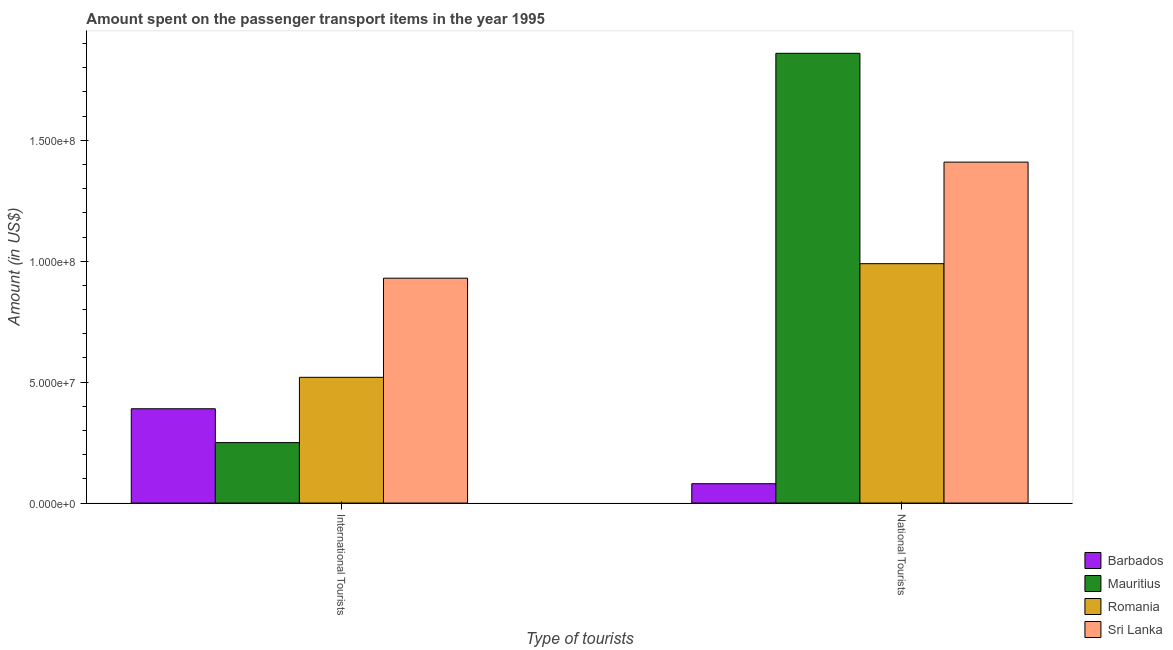How many different coloured bars are there?
Provide a short and direct response. 4. How many groups of bars are there?
Keep it short and to the point. 2. Are the number of bars per tick equal to the number of legend labels?
Ensure brevity in your answer.  Yes. How many bars are there on the 2nd tick from the left?
Give a very brief answer. 4. How many bars are there on the 1st tick from the right?
Provide a short and direct response. 4. What is the label of the 1st group of bars from the left?
Provide a succinct answer. International Tourists. What is the amount spent on transport items of national tourists in Mauritius?
Your answer should be compact. 1.86e+08. Across all countries, what is the maximum amount spent on transport items of national tourists?
Your answer should be very brief. 1.86e+08. Across all countries, what is the minimum amount spent on transport items of international tourists?
Provide a short and direct response. 2.50e+07. In which country was the amount spent on transport items of national tourists maximum?
Keep it short and to the point. Mauritius. In which country was the amount spent on transport items of national tourists minimum?
Offer a terse response. Barbados. What is the total amount spent on transport items of international tourists in the graph?
Give a very brief answer. 2.09e+08. What is the difference between the amount spent on transport items of national tourists in Romania and that in Barbados?
Make the answer very short. 9.10e+07. What is the difference between the amount spent on transport items of international tourists in Barbados and the amount spent on transport items of national tourists in Mauritius?
Ensure brevity in your answer.  -1.47e+08. What is the average amount spent on transport items of national tourists per country?
Offer a very short reply. 1.08e+08. What is the difference between the amount spent on transport items of national tourists and amount spent on transport items of international tourists in Romania?
Offer a very short reply. 4.70e+07. What is the ratio of the amount spent on transport items of international tourists in Barbados to that in Mauritius?
Your answer should be very brief. 1.56. Is the amount spent on transport items of international tourists in Barbados less than that in Sri Lanka?
Your answer should be compact. Yes. In how many countries, is the amount spent on transport items of national tourists greater than the average amount spent on transport items of national tourists taken over all countries?
Your answer should be very brief. 2. What does the 3rd bar from the left in International Tourists represents?
Ensure brevity in your answer.  Romania. What does the 2nd bar from the right in National Tourists represents?
Ensure brevity in your answer.  Romania. How many bars are there?
Keep it short and to the point. 8. How many countries are there in the graph?
Provide a succinct answer. 4. Are the values on the major ticks of Y-axis written in scientific E-notation?
Your response must be concise. Yes. Does the graph contain grids?
Your response must be concise. No. Where does the legend appear in the graph?
Provide a short and direct response. Bottom right. How many legend labels are there?
Your answer should be compact. 4. What is the title of the graph?
Make the answer very short. Amount spent on the passenger transport items in the year 1995. What is the label or title of the X-axis?
Your answer should be compact. Type of tourists. What is the label or title of the Y-axis?
Keep it short and to the point. Amount (in US$). What is the Amount (in US$) in Barbados in International Tourists?
Provide a succinct answer. 3.90e+07. What is the Amount (in US$) in Mauritius in International Tourists?
Your response must be concise. 2.50e+07. What is the Amount (in US$) in Romania in International Tourists?
Offer a very short reply. 5.20e+07. What is the Amount (in US$) of Sri Lanka in International Tourists?
Give a very brief answer. 9.30e+07. What is the Amount (in US$) in Mauritius in National Tourists?
Offer a terse response. 1.86e+08. What is the Amount (in US$) of Romania in National Tourists?
Keep it short and to the point. 9.90e+07. What is the Amount (in US$) in Sri Lanka in National Tourists?
Make the answer very short. 1.41e+08. Across all Type of tourists, what is the maximum Amount (in US$) in Barbados?
Ensure brevity in your answer.  3.90e+07. Across all Type of tourists, what is the maximum Amount (in US$) of Mauritius?
Your answer should be very brief. 1.86e+08. Across all Type of tourists, what is the maximum Amount (in US$) in Romania?
Your answer should be compact. 9.90e+07. Across all Type of tourists, what is the maximum Amount (in US$) of Sri Lanka?
Give a very brief answer. 1.41e+08. Across all Type of tourists, what is the minimum Amount (in US$) of Mauritius?
Provide a short and direct response. 2.50e+07. Across all Type of tourists, what is the minimum Amount (in US$) in Romania?
Provide a succinct answer. 5.20e+07. Across all Type of tourists, what is the minimum Amount (in US$) in Sri Lanka?
Give a very brief answer. 9.30e+07. What is the total Amount (in US$) in Barbados in the graph?
Keep it short and to the point. 4.70e+07. What is the total Amount (in US$) of Mauritius in the graph?
Your response must be concise. 2.11e+08. What is the total Amount (in US$) of Romania in the graph?
Your answer should be compact. 1.51e+08. What is the total Amount (in US$) in Sri Lanka in the graph?
Provide a succinct answer. 2.34e+08. What is the difference between the Amount (in US$) of Barbados in International Tourists and that in National Tourists?
Ensure brevity in your answer.  3.10e+07. What is the difference between the Amount (in US$) in Mauritius in International Tourists and that in National Tourists?
Provide a succinct answer. -1.61e+08. What is the difference between the Amount (in US$) in Romania in International Tourists and that in National Tourists?
Keep it short and to the point. -4.70e+07. What is the difference between the Amount (in US$) of Sri Lanka in International Tourists and that in National Tourists?
Give a very brief answer. -4.80e+07. What is the difference between the Amount (in US$) in Barbados in International Tourists and the Amount (in US$) in Mauritius in National Tourists?
Your answer should be compact. -1.47e+08. What is the difference between the Amount (in US$) in Barbados in International Tourists and the Amount (in US$) in Romania in National Tourists?
Offer a terse response. -6.00e+07. What is the difference between the Amount (in US$) of Barbados in International Tourists and the Amount (in US$) of Sri Lanka in National Tourists?
Keep it short and to the point. -1.02e+08. What is the difference between the Amount (in US$) of Mauritius in International Tourists and the Amount (in US$) of Romania in National Tourists?
Give a very brief answer. -7.40e+07. What is the difference between the Amount (in US$) in Mauritius in International Tourists and the Amount (in US$) in Sri Lanka in National Tourists?
Ensure brevity in your answer.  -1.16e+08. What is the difference between the Amount (in US$) in Romania in International Tourists and the Amount (in US$) in Sri Lanka in National Tourists?
Make the answer very short. -8.90e+07. What is the average Amount (in US$) in Barbados per Type of tourists?
Provide a short and direct response. 2.35e+07. What is the average Amount (in US$) of Mauritius per Type of tourists?
Keep it short and to the point. 1.06e+08. What is the average Amount (in US$) of Romania per Type of tourists?
Provide a succinct answer. 7.55e+07. What is the average Amount (in US$) in Sri Lanka per Type of tourists?
Ensure brevity in your answer.  1.17e+08. What is the difference between the Amount (in US$) of Barbados and Amount (in US$) of Mauritius in International Tourists?
Offer a terse response. 1.40e+07. What is the difference between the Amount (in US$) in Barbados and Amount (in US$) in Romania in International Tourists?
Offer a very short reply. -1.30e+07. What is the difference between the Amount (in US$) in Barbados and Amount (in US$) in Sri Lanka in International Tourists?
Give a very brief answer. -5.40e+07. What is the difference between the Amount (in US$) in Mauritius and Amount (in US$) in Romania in International Tourists?
Ensure brevity in your answer.  -2.70e+07. What is the difference between the Amount (in US$) in Mauritius and Amount (in US$) in Sri Lanka in International Tourists?
Make the answer very short. -6.80e+07. What is the difference between the Amount (in US$) of Romania and Amount (in US$) of Sri Lanka in International Tourists?
Your answer should be compact. -4.10e+07. What is the difference between the Amount (in US$) of Barbados and Amount (in US$) of Mauritius in National Tourists?
Your answer should be very brief. -1.78e+08. What is the difference between the Amount (in US$) of Barbados and Amount (in US$) of Romania in National Tourists?
Your answer should be compact. -9.10e+07. What is the difference between the Amount (in US$) in Barbados and Amount (in US$) in Sri Lanka in National Tourists?
Provide a succinct answer. -1.33e+08. What is the difference between the Amount (in US$) of Mauritius and Amount (in US$) of Romania in National Tourists?
Give a very brief answer. 8.70e+07. What is the difference between the Amount (in US$) in Mauritius and Amount (in US$) in Sri Lanka in National Tourists?
Your answer should be very brief. 4.50e+07. What is the difference between the Amount (in US$) of Romania and Amount (in US$) of Sri Lanka in National Tourists?
Your answer should be very brief. -4.20e+07. What is the ratio of the Amount (in US$) in Barbados in International Tourists to that in National Tourists?
Provide a short and direct response. 4.88. What is the ratio of the Amount (in US$) of Mauritius in International Tourists to that in National Tourists?
Keep it short and to the point. 0.13. What is the ratio of the Amount (in US$) in Romania in International Tourists to that in National Tourists?
Your response must be concise. 0.53. What is the ratio of the Amount (in US$) in Sri Lanka in International Tourists to that in National Tourists?
Offer a terse response. 0.66. What is the difference between the highest and the second highest Amount (in US$) of Barbados?
Provide a short and direct response. 3.10e+07. What is the difference between the highest and the second highest Amount (in US$) in Mauritius?
Offer a terse response. 1.61e+08. What is the difference between the highest and the second highest Amount (in US$) in Romania?
Make the answer very short. 4.70e+07. What is the difference between the highest and the second highest Amount (in US$) of Sri Lanka?
Make the answer very short. 4.80e+07. What is the difference between the highest and the lowest Amount (in US$) of Barbados?
Make the answer very short. 3.10e+07. What is the difference between the highest and the lowest Amount (in US$) in Mauritius?
Keep it short and to the point. 1.61e+08. What is the difference between the highest and the lowest Amount (in US$) of Romania?
Offer a very short reply. 4.70e+07. What is the difference between the highest and the lowest Amount (in US$) in Sri Lanka?
Offer a terse response. 4.80e+07. 